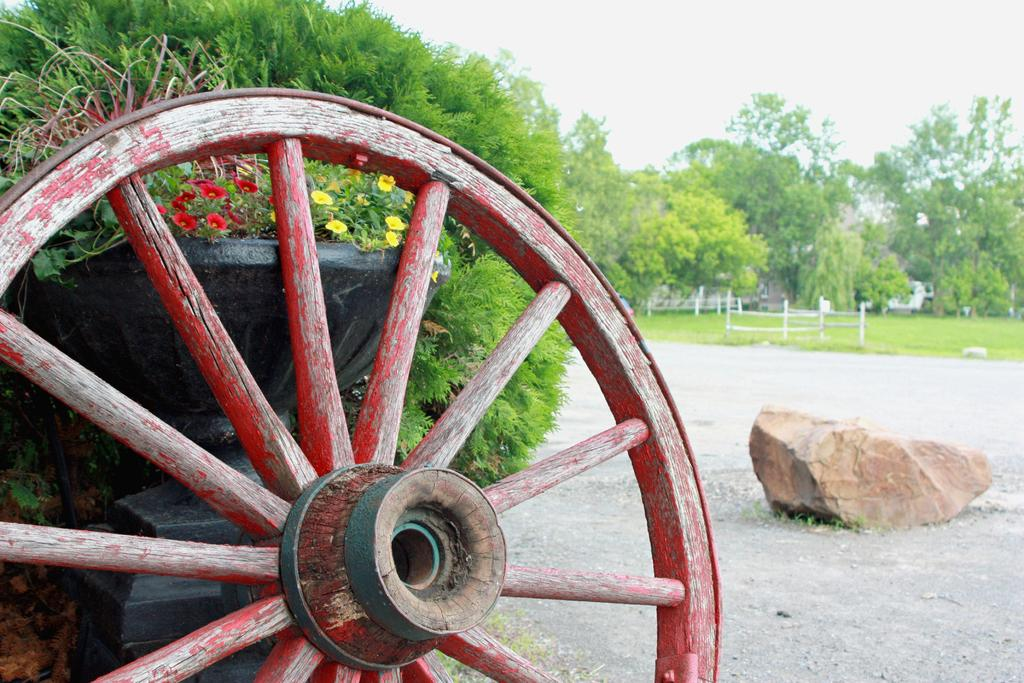What object can be seen on the road in the image? There is a wheel on the road in the image. What else is present in the image besides the wheel? There are plants in a pot and trees visible in the image. How many cars are being born in the image? There are no cars or references to birth in the image. 